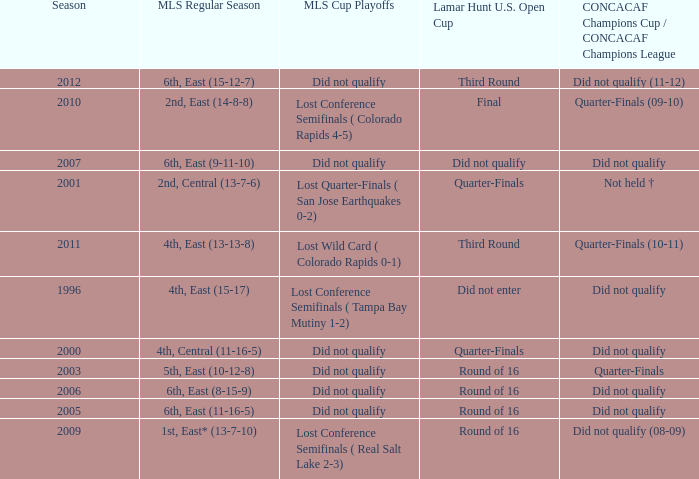What was the lamar hunt u.s. open cup when concacaf champions cup / concacaf champions league was did not qualify and mls regular season was 4th, central (11-16-5)? Quarter-Finals. 